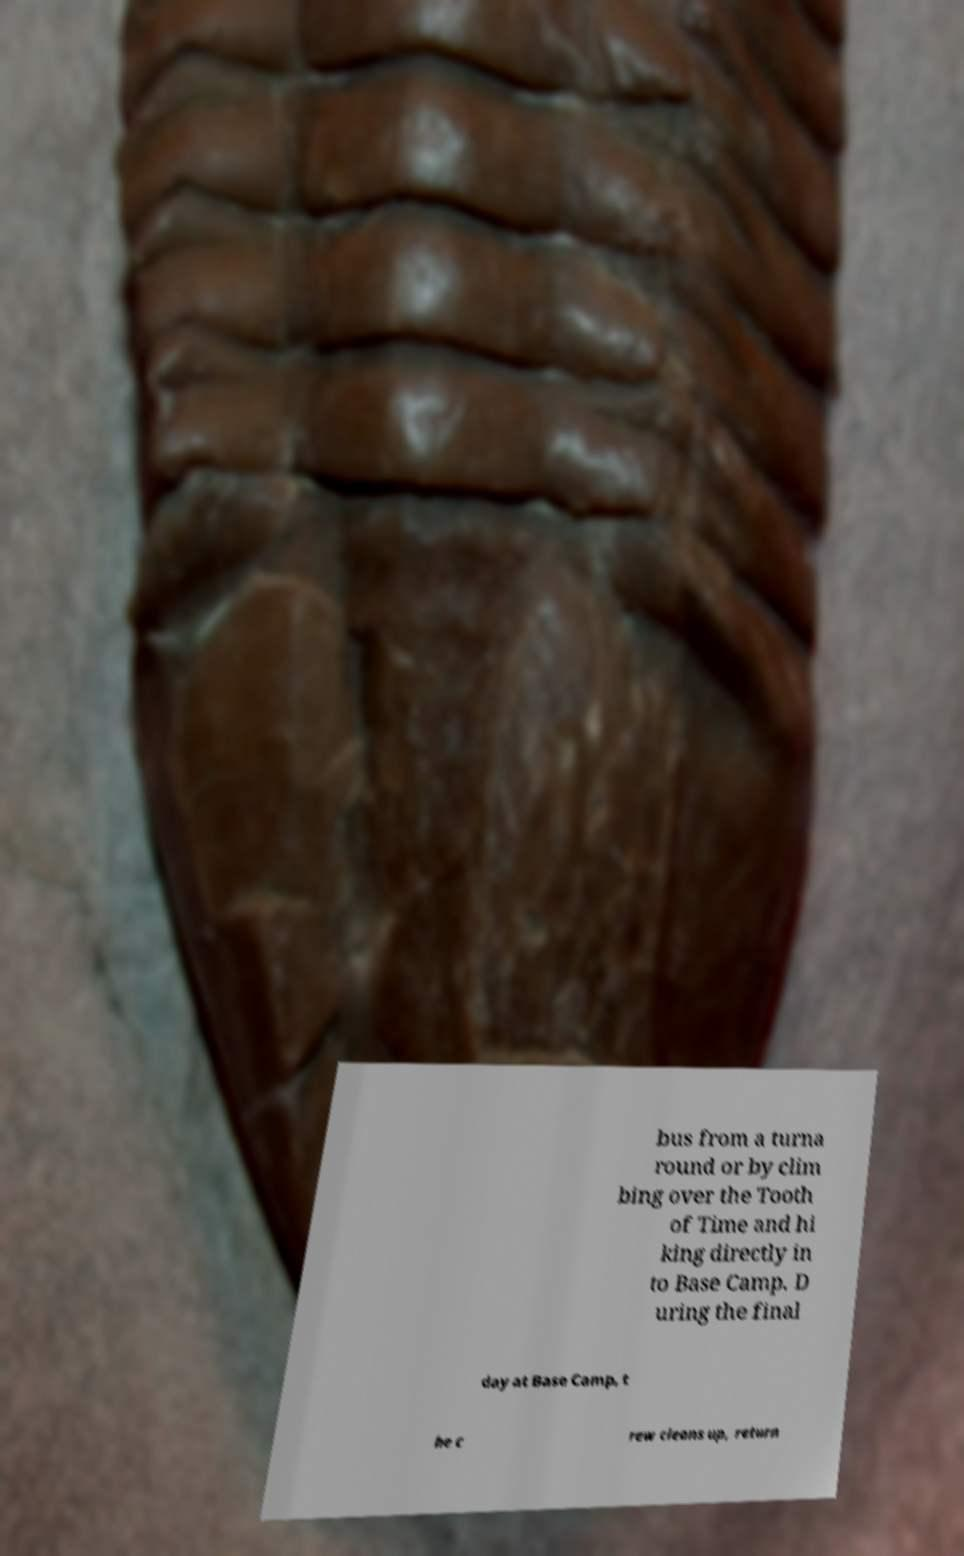I need the written content from this picture converted into text. Can you do that? bus from a turna round or by clim bing over the Tooth of Time and hi king directly in to Base Camp. D uring the final day at Base Camp, t he c rew cleans up, return 